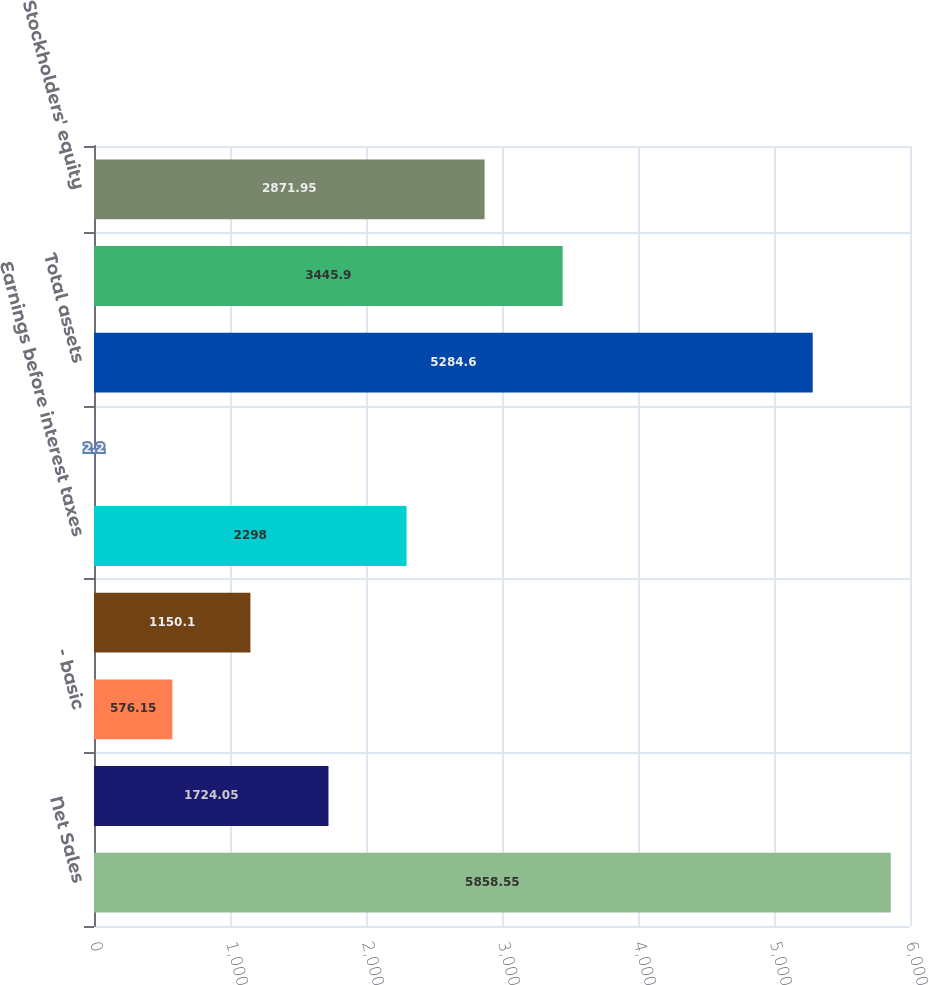Convert chart. <chart><loc_0><loc_0><loc_500><loc_500><bar_chart><fcel>Net Sales<fcel>Net Income<fcel>- basic<fcel>- diluted<fcel>Earnings before interest taxes<fcel>Cash dividends declared per<fcel>Total assets<fcel>Total debt obligations<fcel>Stockholders' equity<nl><fcel>5858.55<fcel>1724.05<fcel>576.15<fcel>1150.1<fcel>2298<fcel>2.2<fcel>5284.6<fcel>3445.9<fcel>2871.95<nl></chart> 